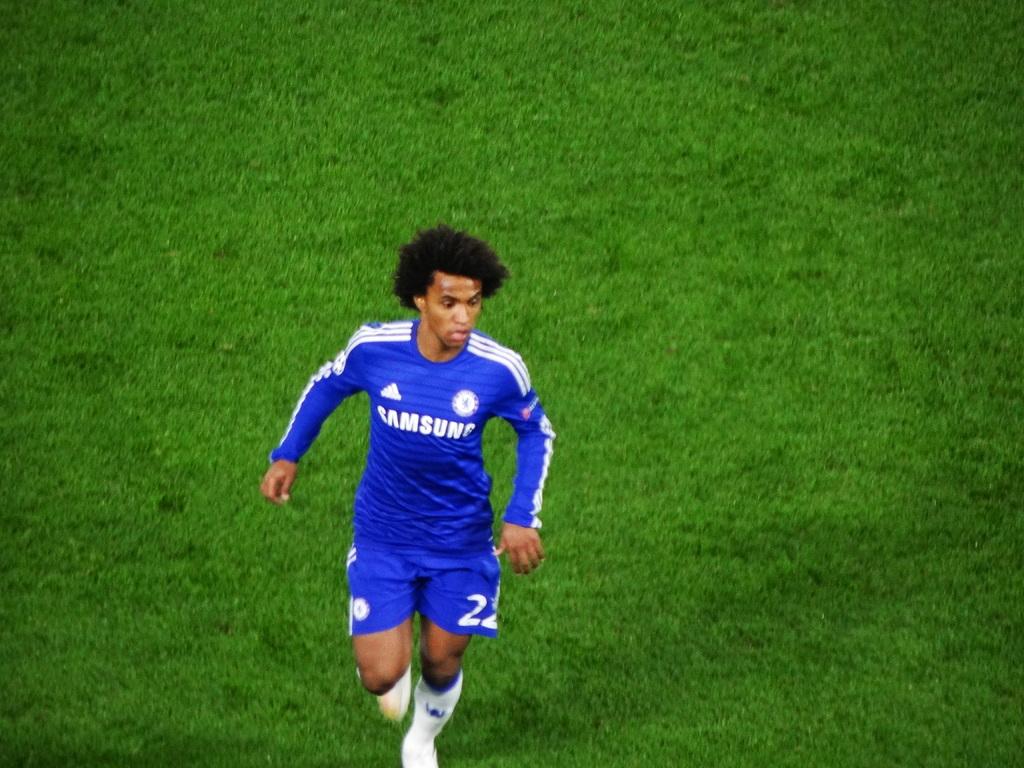What company sponsors this team?
Provide a short and direct response. Samsung. 